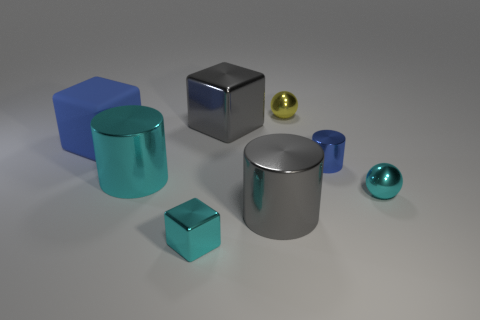Add 1 blue metallic cylinders. How many objects exist? 9 Subtract all cylinders. How many objects are left? 5 Subtract 1 cyan cylinders. How many objects are left? 7 Subtract all brown matte blocks. Subtract all cyan cylinders. How many objects are left? 7 Add 5 gray metallic cylinders. How many gray metallic cylinders are left? 6 Add 3 cyan metallic cylinders. How many cyan metallic cylinders exist? 4 